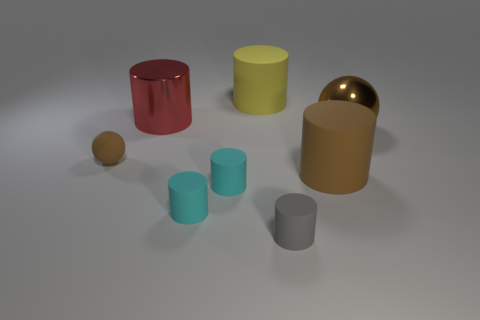Subtract all brown rubber cylinders. How many cylinders are left? 5 Subtract all green balls. How many cyan cylinders are left? 2 Subtract all yellow cylinders. How many cylinders are left? 5 Add 2 big cylinders. How many objects exist? 10 Subtract all gray cylinders. Subtract all red cubes. How many cylinders are left? 5 Subtract all cylinders. How many objects are left? 2 Subtract 0 purple cylinders. How many objects are left? 8 Subtract all brown rubber spheres. Subtract all big rubber cylinders. How many objects are left? 5 Add 4 tiny cyan rubber things. How many tiny cyan rubber things are left? 6 Add 6 matte cubes. How many matte cubes exist? 6 